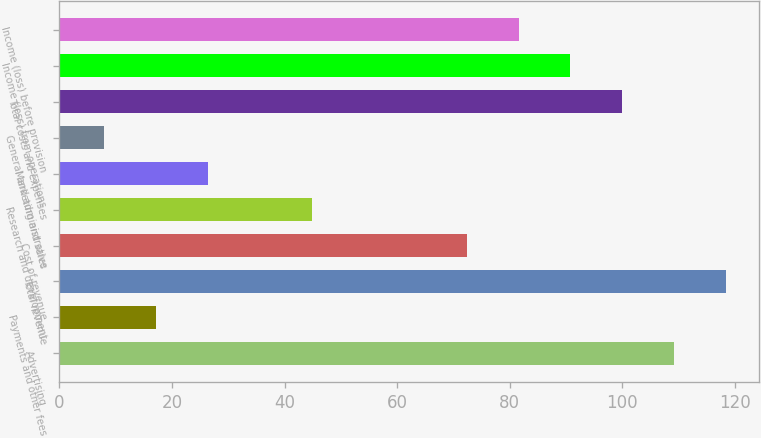<chart> <loc_0><loc_0><loc_500><loc_500><bar_chart><fcel>Advertising<fcel>Payments and other fees<fcel>Total revenue<fcel>Cost of revenue<fcel>Research and development<fcel>Marketing and sales<fcel>General and administrative<fcel>Total costs and expenses<fcel>Income (loss) from operations<fcel>Income (loss) before provision<nl><fcel>109.2<fcel>17.2<fcel>118.4<fcel>72.4<fcel>44.8<fcel>26.4<fcel>8<fcel>100<fcel>90.8<fcel>81.6<nl></chart> 